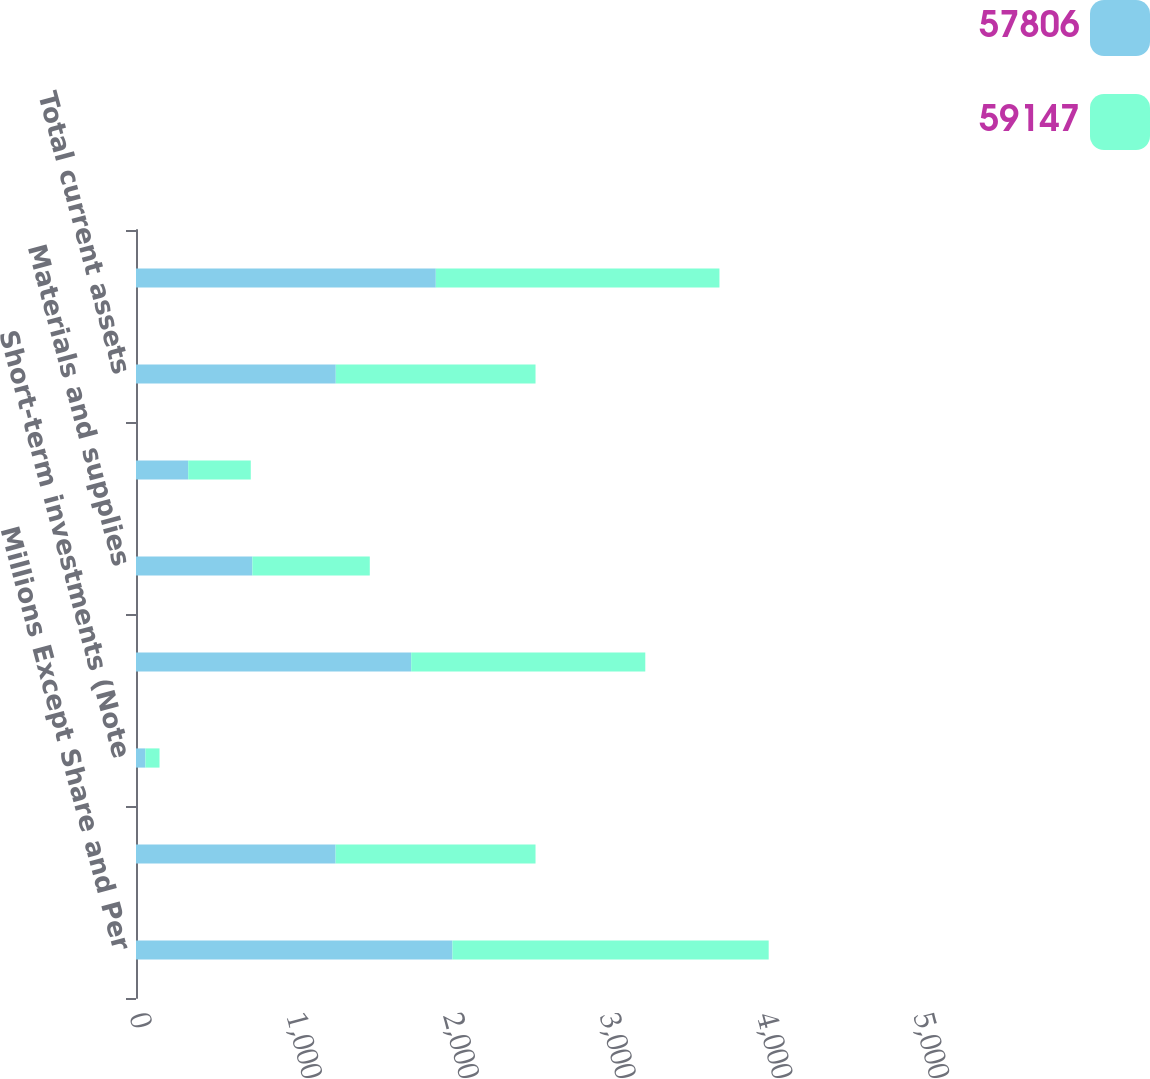Convert chart to OTSL. <chart><loc_0><loc_0><loc_500><loc_500><stacked_bar_chart><ecel><fcel>Millions Except Share and Per<fcel>Cash and cash equivalents<fcel>Short-term investments (Note<fcel>Accounts receivable net (Note<fcel>Materials and supplies<fcel>Other current assets<fcel>Total current assets<fcel>Investments<nl><fcel>57806<fcel>2018<fcel>1273<fcel>60<fcel>1755<fcel>742<fcel>333<fcel>1274<fcel>1912<nl><fcel>59147<fcel>2017<fcel>1275<fcel>90<fcel>1493<fcel>749<fcel>399<fcel>1274<fcel>1809<nl></chart> 